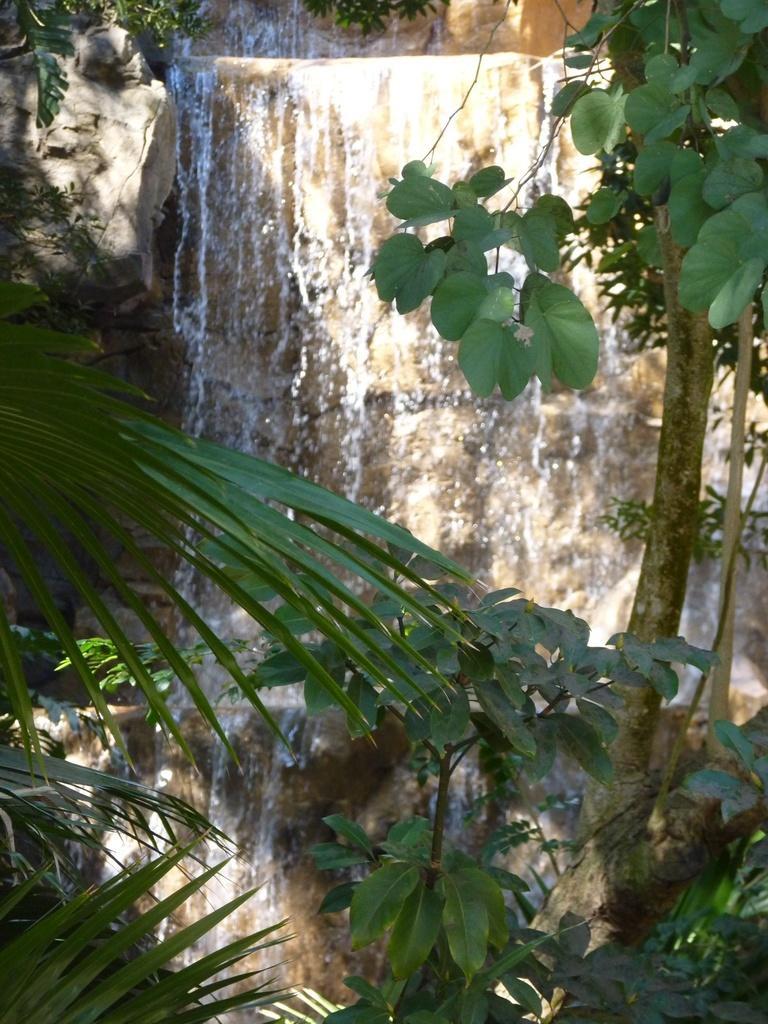In one or two sentences, can you explain what this image depicts? In this picture there is a wall in the center of the image and there are plants on the right and left side of the image. 